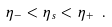Convert formula to latex. <formula><loc_0><loc_0><loc_500><loc_500>\eta _ { - } < \eta _ { s } < \eta _ { + } \ .</formula> 